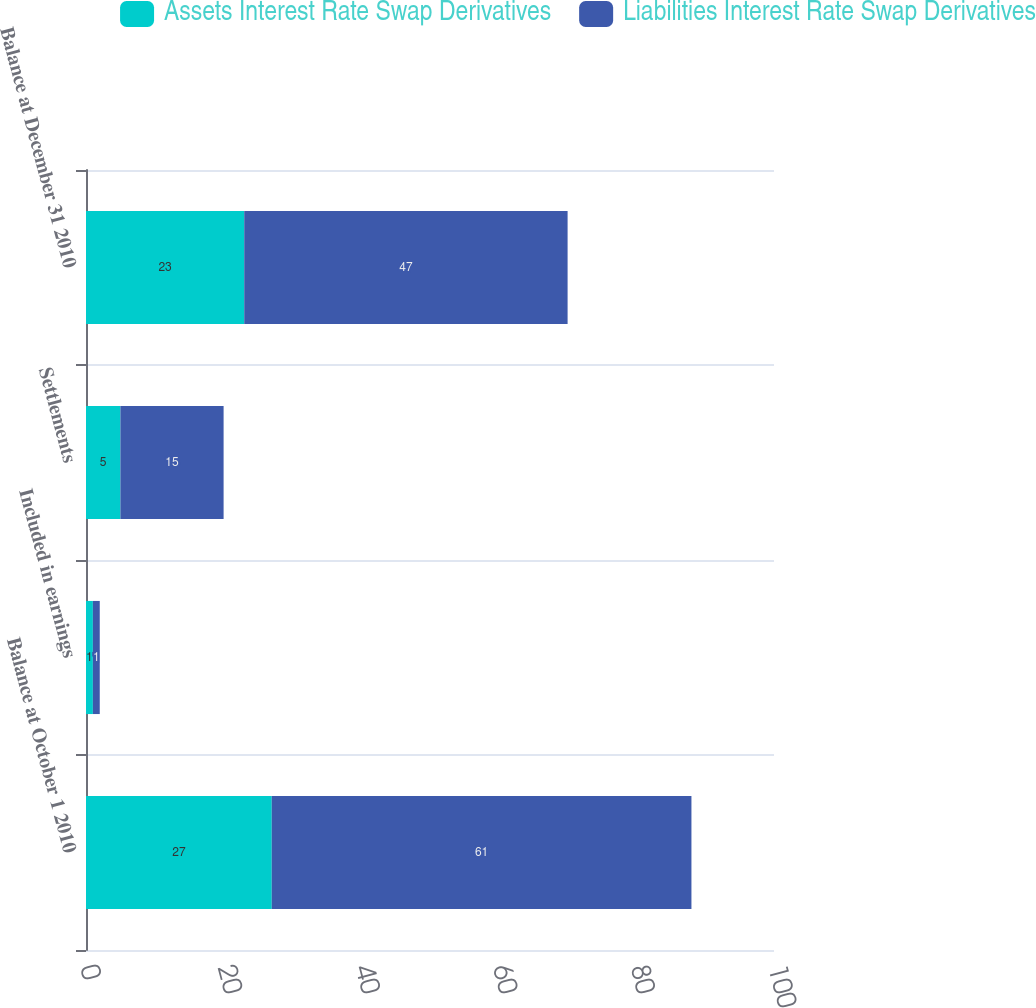Convert chart to OTSL. <chart><loc_0><loc_0><loc_500><loc_500><stacked_bar_chart><ecel><fcel>Balance at October 1 2010<fcel>Included in earnings<fcel>Settlements<fcel>Balance at December 31 2010<nl><fcel>Assets Interest Rate Swap Derivatives<fcel>27<fcel>1<fcel>5<fcel>23<nl><fcel>Liabilities Interest Rate Swap Derivatives<fcel>61<fcel>1<fcel>15<fcel>47<nl></chart> 